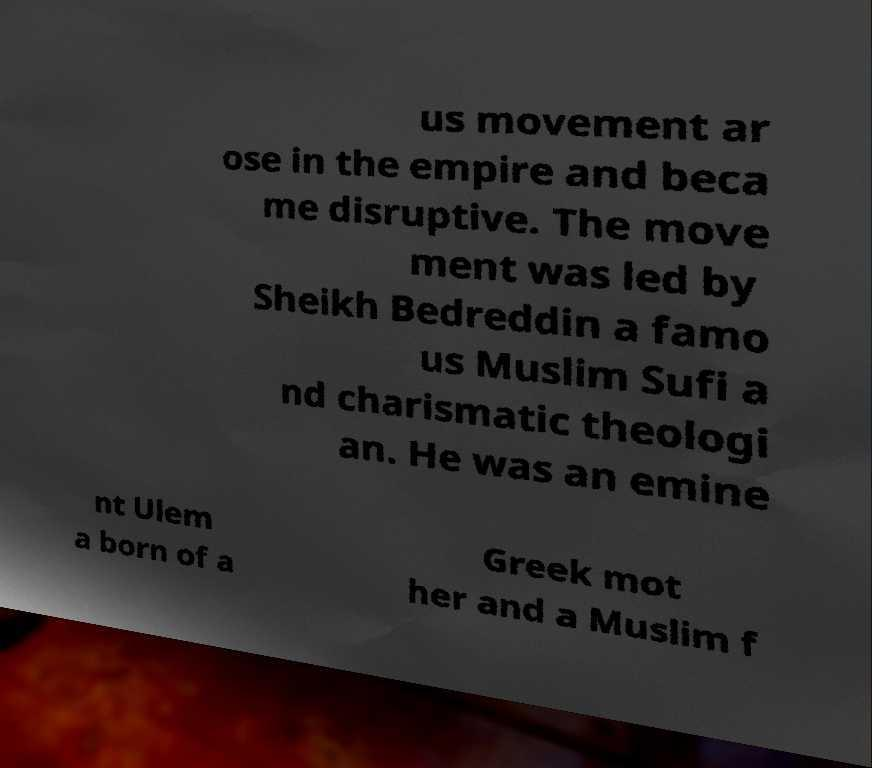Please read and relay the text visible in this image. What does it say? us movement ar ose in the empire and beca me disruptive. The move ment was led by Sheikh Bedreddin a famo us Muslim Sufi a nd charismatic theologi an. He was an emine nt Ulem a born of a Greek mot her and a Muslim f 